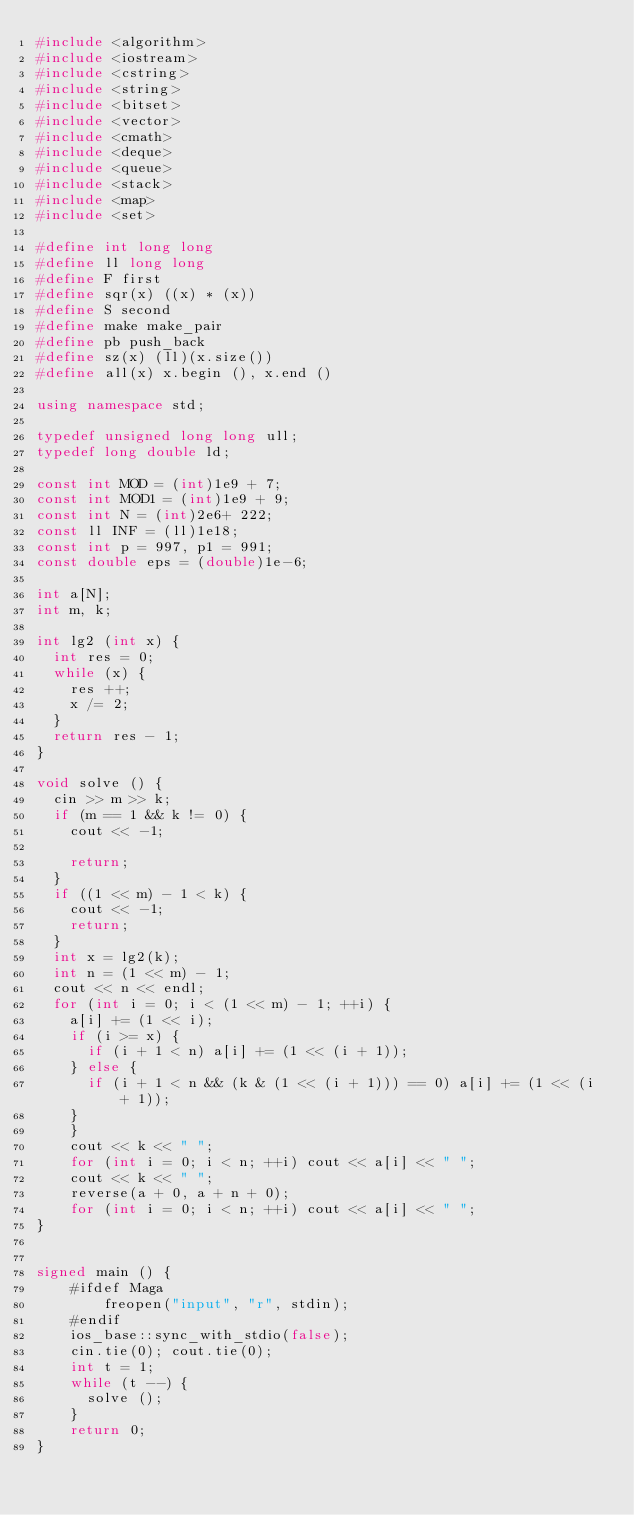<code> <loc_0><loc_0><loc_500><loc_500><_C++_>#include <algorithm>
#include <iostream>
#include <cstring>
#include <string>
#include <bitset> 
#include <vector>
#include <cmath>
#include <deque>
#include <queue>
#include <stack>
#include <map>
#include <set>
 
#define int long long
#define ll long long 
#define F first
#define sqr(x) ((x) * (x))
#define S second
#define make make_pair
#define pb push_back
#define sz(x) (ll)(x.size()) 
#define all(x) x.begin (), x.end ()

using namespace std;
                        
typedef unsigned long long ull;
typedef long double ld;

const int MOD = (int)1e9 + 7;
const int MOD1 = (int)1e9 + 9;
const int N = (int)2e6+ 222;
const ll INF = (ll)1e18;
const int p = 997, p1 = 991;
const double eps = (double)1e-6;
     
int a[N];
int m, k;

int lg2 (int x) {
	int res = 0;
	while (x) {
		res ++;
		x /= 2;
	}
	return res - 1;
}
             
void solve () {                                                
	cin >> m >> k;
	if (m == 1 && k != 0) {
		cout << -1;

		return;
	}
	if ((1 << m) - 1 < k) {
		cout << -1;
		return;
	}
	int x = lg2(k);
	int n = (1 << m) - 1;
	cout << n << endl;
	for (int i = 0; i < (1 << m) - 1; ++i) {
		a[i] += (1 << i);
		if (i >= x) {
			if (i + 1 < n) a[i] += (1 << (i + 1));
		} else {
		 	if (i + 1 < n && (k & (1 << (i + 1))) == 0) a[i] += (1 << (i + 1));
		}
    }
    cout << k << " ";
    for (int i = 0; i < n; ++i) cout << a[i] << " ";
    cout << k << " ";
    reverse(a + 0, a + n + 0); 
    for (int i = 0; i < n; ++i) cout << a[i] << " ";
}


signed main () {
    #ifdef Maga
        freopen("input", "r", stdin);
    #endif
    ios_base::sync_with_stdio(false);
    cin.tie(0); cout.tie(0);                                              
    int t = 1;
    while (t --) {
    	solve ();
    }
    return 0;
}



</code> 